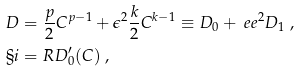<formula> <loc_0><loc_0><loc_500><loc_500>& D = \frac { p } { 2 } C ^ { p - 1 } + \epsilon ^ { 2 } \frac { k } { 2 } C ^ { k - 1 } \equiv D _ { 0 } + \ e e ^ { 2 } D _ { 1 } \ , \\ & \S i = R D ^ { \prime } _ { 0 } ( C ) \ ,</formula> 